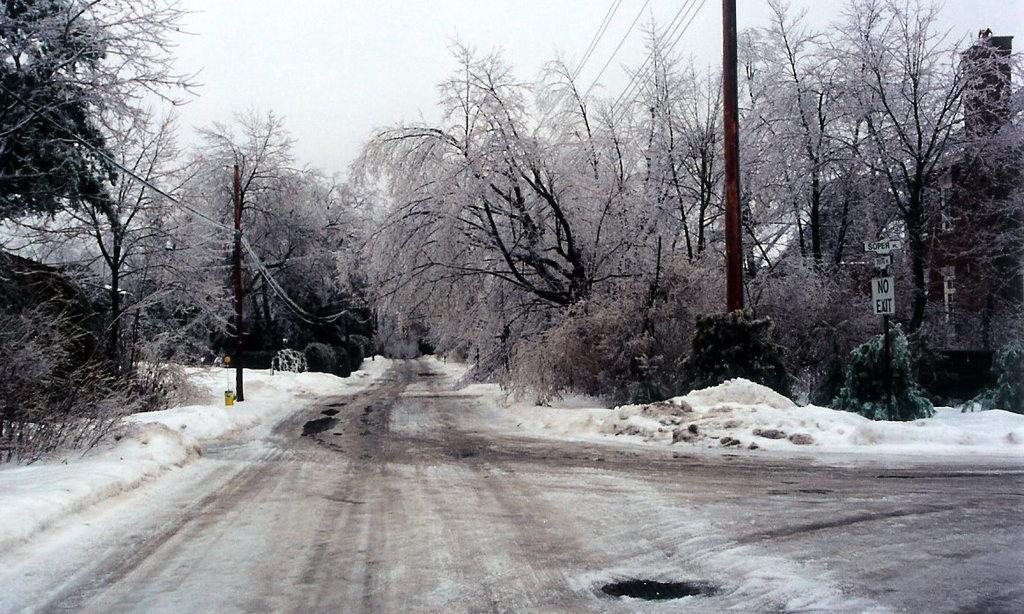Please provide a concise description of this image. In the middle it is a road, which is covered with the snow and there are trees on either side of this road. In the right side there is a sign board. 